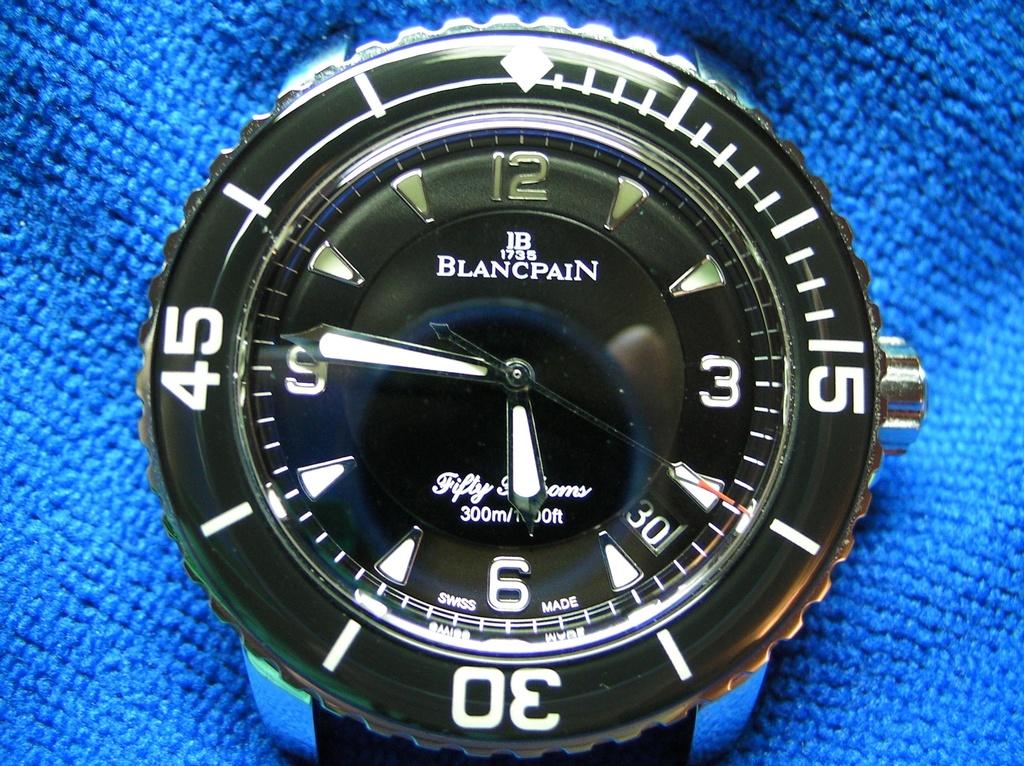What watch brand is thia?
Keep it short and to the point. Blancpain. Where is the watch band?
Keep it short and to the point. Blancpain. 